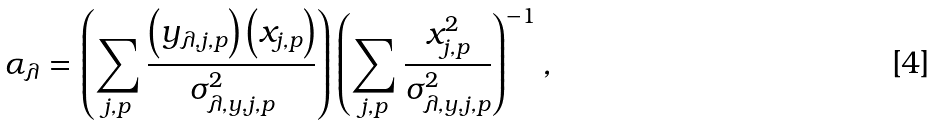Convert formula to latex. <formula><loc_0><loc_0><loc_500><loc_500>\alpha _ { \lambda } = \left ( \sum _ { j , p } \frac { \left ( y _ { \lambda , j , p } \right ) \left ( x _ { j , p } \right ) } { \sigma _ { \lambda , y , j , p } ^ { 2 } } \right ) \left ( \sum _ { j , p } \frac { x _ { j , p } ^ { 2 } } { \sigma _ { \lambda , y , j , p } ^ { 2 } } \right ) ^ { - 1 } ,</formula> 